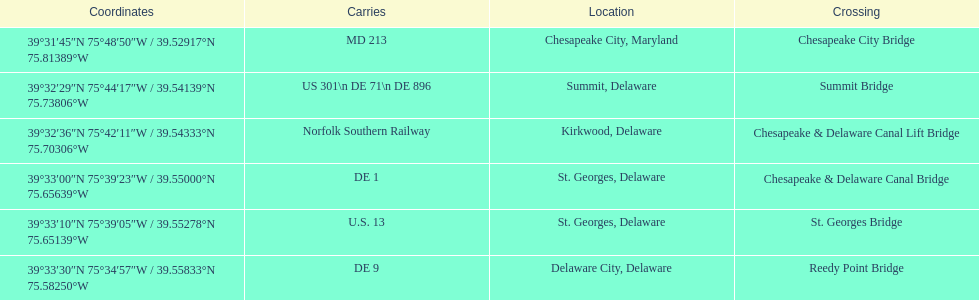How many crossings are in maryland? 1. 